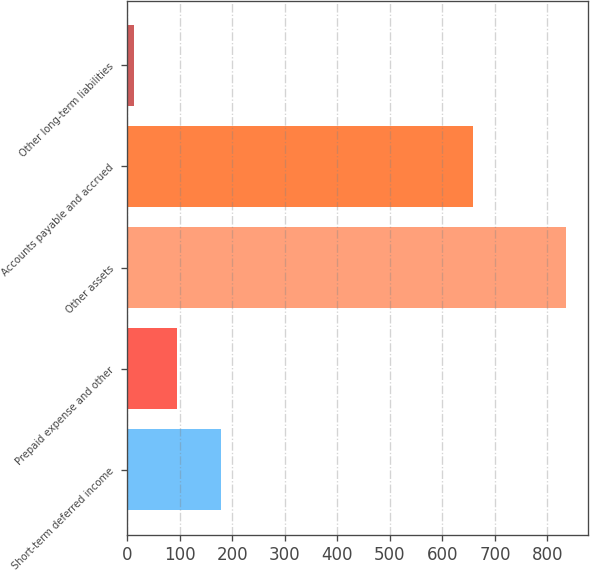<chart> <loc_0><loc_0><loc_500><loc_500><bar_chart><fcel>Short-term deferred income<fcel>Prepaid expense and other<fcel>Other assets<fcel>Accounts payable and accrued<fcel>Other long-term liabilities<nl><fcel>177.6<fcel>95.3<fcel>836<fcel>658<fcel>13<nl></chart> 